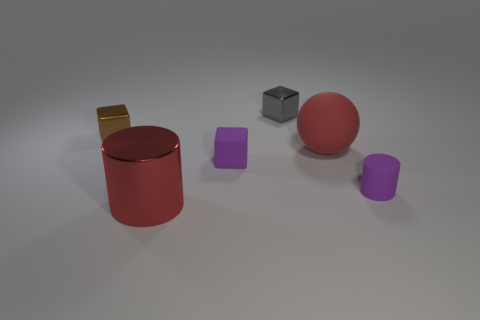Is the number of small purple matte cylinders less than the number of tiny green cylinders?
Provide a succinct answer. No. There is a large metallic object to the left of the rubber sphere; does it have the same color as the ball?
Make the answer very short. Yes. What is the material of the red thing that is in front of the small matte object that is left of the shiny block that is right of the red metal cylinder?
Your answer should be compact. Metal. Is there a large matte sphere of the same color as the large metallic object?
Your answer should be very brief. Yes. Are there fewer tiny metallic things to the right of the large red rubber thing than tiny purple rubber objects?
Your response must be concise. Yes. There is a purple object to the right of the purple block; is it the same size as the tiny brown shiny block?
Provide a short and direct response. Yes. What number of things are behind the purple block and to the right of the tiny purple cube?
Keep it short and to the point. 2. There is a metallic block left of the large thing that is left of the red ball; what size is it?
Keep it short and to the point. Small. Are there fewer gray blocks that are behind the tiny gray cube than purple blocks that are right of the red shiny object?
Your answer should be very brief. Yes. There is a cylinder to the left of the red rubber object; is it the same color as the big object that is to the right of the gray object?
Your response must be concise. Yes. 